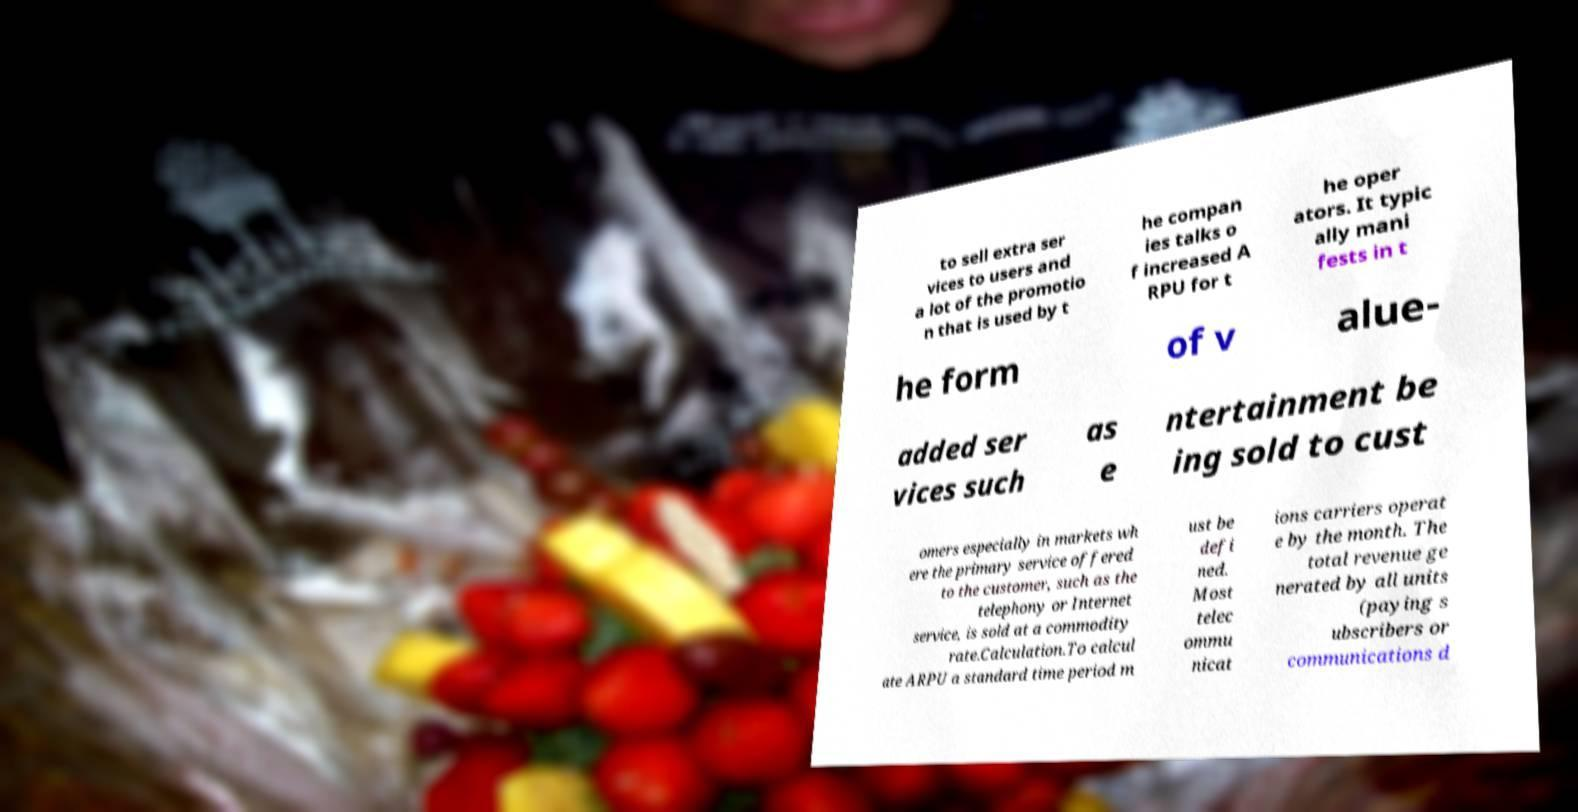For documentation purposes, I need the text within this image transcribed. Could you provide that? to sell extra ser vices to users and a lot of the promotio n that is used by t he compan ies talks o f increased A RPU for t he oper ators. It typic ally mani fests in t he form of v alue- added ser vices such as e ntertainment be ing sold to cust omers especially in markets wh ere the primary service offered to the customer, such as the telephony or Internet service, is sold at a commodity rate.Calculation.To calcul ate ARPU a standard time period m ust be defi ned. Most telec ommu nicat ions carriers operat e by the month. The total revenue ge nerated by all units (paying s ubscribers or communications d 